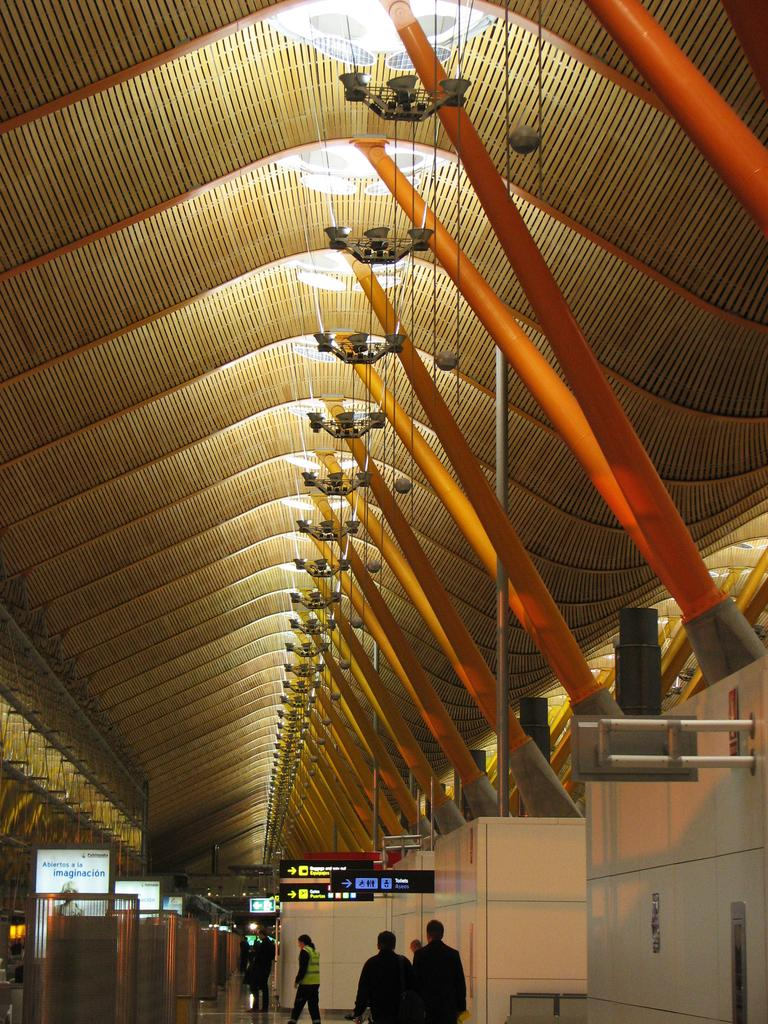What are the people in the image doing? The people in the image are walking. What can be seen at the top of the image? There are lights visible at the top of the image. What is located on the left side of the image? There are boards on the left side of the image. Can you see the doll's lip in the image? There is no doll present in the image, so it is not possible to see the doll's lip. 